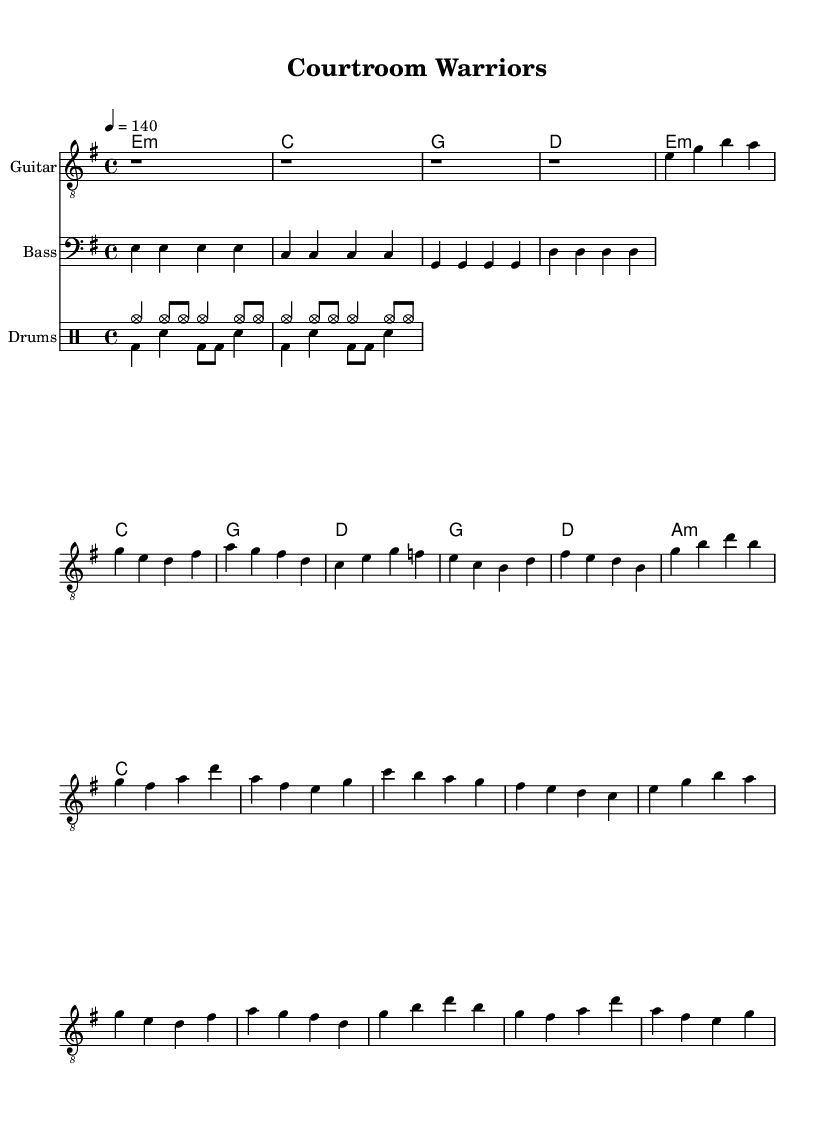What is the key signature of this music? The key signature is indicated by the sharps or flats at the beginning of the staff. In this piece, there are no sharps or flats shown, indicating it is in E minor, which contains one sharp (F#).
Answer: E minor What is the time signature of this music? The time signature is shown at the beginning of the staff and indicates how many beats are in each measure and what note value gets the beat. Here, the time signature is 4/4, meaning there are 4 beats per measure and the quarter note receives one beat.
Answer: 4/4 What is the tempo of this music? The tempo is provided at the beginning of the piece and indicates the speed. This music has a tempo of 140 beats per minute, specified as "4 = 140".
Answer: 140 What is the first chord in the music? The first chord is indicated at the start of the piece under the chord names. The first chord is E minor, which is represented as e:m.
Answer: E minor How many times is the chorus played in the piece? To determine the number of times the chorus is played, you can count the occurrences of the chorus lyrics in the lyrics section. The chorus appears twice throughout the piece.
Answer: Twice What type of musical dynamics can be inferred from the drums section? The drums section consists primarily of basic rock beats that suggest a consistent and impactful sound common in hard rock music, characterized by a driving rhythm throughout. This indicates an energetic dynamic suitable for an anthem.
Answer: Energetic What section of the song contains lyrics about standing tall and proud? The lyrics about standing tall and proud are found in the first verse, which emphasizes determination and strength in facing challenges in a courtroom setting.
Answer: Verse 